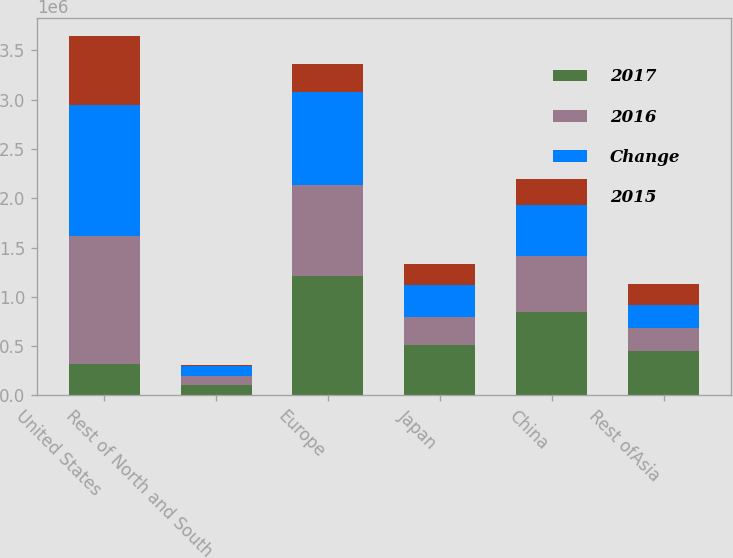<chart> <loc_0><loc_0><loc_500><loc_500><stacked_bar_chart><ecel><fcel>United States<fcel>Rest of North and South<fcel>Europe<fcel>Japan<fcel>China<fcel>Rest ofAsia<nl><fcel>2017<fcel>319569<fcel>103077<fcel>1.21144e+06<fcel>506114<fcel>842532<fcel>445304<nl><fcel>2016<fcel>1.29963e+06<fcel>95957<fcel>924849<fcel>291649<fcel>575690<fcel>233635<nl><fcel>Change<fcel>1.32528e+06<fcel>97189<fcel>939230<fcel>319569<fcel>511365<fcel>242460<nl><fcel>2015<fcel>699412<fcel>7120<fcel>286586<fcel>214465<fcel>266842<fcel>211669<nl></chart> 